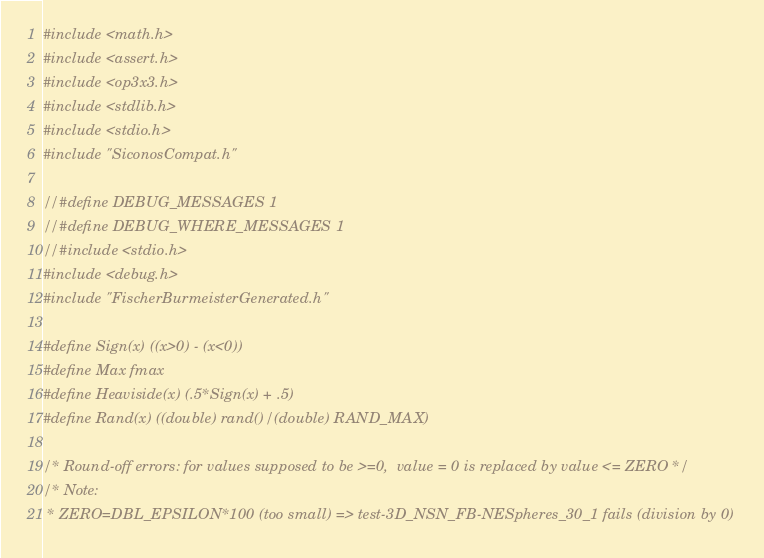Convert code to text. <code><loc_0><loc_0><loc_500><loc_500><_C_>#include <math.h>
#include <assert.h>
#include <op3x3.h>
#include <stdlib.h>
#include <stdio.h>
#include "SiconosCompat.h"

//#define DEBUG_MESSAGES 1
//#define DEBUG_WHERE_MESSAGES 1
//#include <stdio.h>
#include <debug.h>
#include "FischerBurmeisterGenerated.h"

#define Sign(x) ((x>0) - (x<0))
#define Max fmax
#define Heaviside(x) (.5*Sign(x) + .5)
#define Rand(x) ((double) rand()/ (double) RAND_MAX)

/* Round-off errors: for values supposed to be >=0,  value = 0 is replaced by value <= ZERO */
/* Note:
 * ZERO=DBL_EPSILON*100 (too small) => test-3D_NSN_FB-NESpheres_30_1 fails (division by 0)</code> 